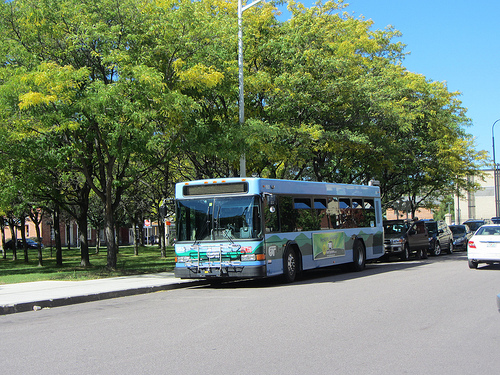If the image were to come alive, what sounds and activities could you expect? If the image came to life, one could expect to hear the sounds of the bus engine idling and doors opening and closing, the rustle of leaves on the trees as a gentle breeze passes through, and the distant chatter of pedestrians and children. There might be the occasional honk from a car, signaling a driver’s urgency, coupled with the ambient noises of birds chirping, further enriching the lively urban atmosphere. 